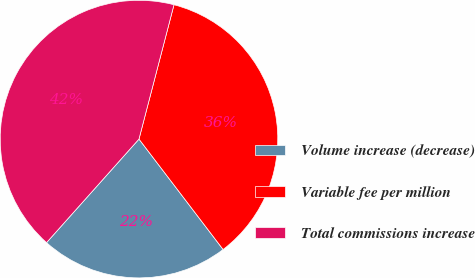Convert chart. <chart><loc_0><loc_0><loc_500><loc_500><pie_chart><fcel>Volume increase (decrease)<fcel>Variable fee per million<fcel>Total commissions increase<nl><fcel>21.96%<fcel>35.58%<fcel>42.46%<nl></chart> 